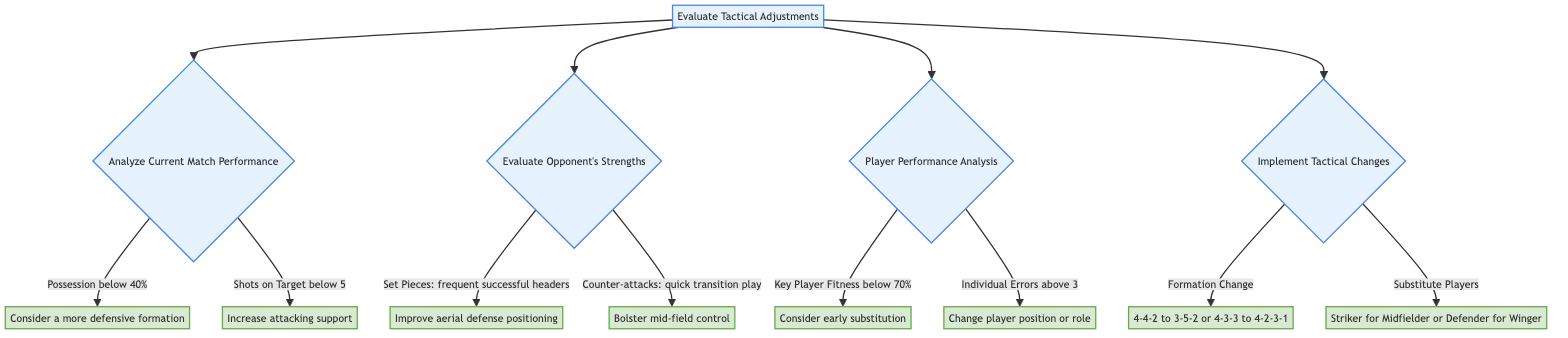What is the first node of the decision tree? The decision tree begins with the node titled "Evaluate Tactical Adjustments." This is the root node from which all subsequent decisions branch out.
Answer: Evaluate Tactical Adjustments How many main branches are there in this decision tree? The decision tree has four main branches stemming from the root node. Each branch represents a different aspect of tactical evaluation: current match performance, opponent's strengths, player performance, and implementing tactical changes.
Answer: 4 What action is suggested if possession is below 40%? The decision tree indicates that if possession is below 40%, the recommended action is to "Consider a more defensive formation." This suggests a tactical adjustment to improve ball control.
Answer: Consider a more defensive formation What should be done if individual errors are above 3? According to the diagram, if there are more than 3 individual errors, the recommended action is to "Change player position or role." This indicates a need to rectify performance issues.
Answer: Change player position or role What are the two options for a formation change? The decision tree provides two options for formation change: changing from "4-4-2 to 3-5-2" or from "4-3-3 to 4-2-3-1." Both options offer different tactical setups depending on match dynamics.
Answer: 4-4-2 to 3-5-2 or 4-3-3 to 4-2-3-1 What is the decision made when counter-attacks are frequent? If counter-attacks from the opponent involve quick transition play, the decision made is to "Bolster mid-field control." This aims to disrupt the opponent's attacking rhythm.
Answer: Bolster mid-field control What action should be taken if a key player's fitness is below 70%? The diagram advises that if a key player's fitness is below 70%, the action to be taken is to "Consider early substitution." This reflects a proactive approach to player management during a match.
Answer: Consider early substitution How are substitute players determined according to the decision tree? The decision on substitutes depends on identifying weak areas. The options presented are to substitute either a striker for a midfielder or a defender for a winger, based on the tactical evaluation.
Answer: Striker for Midfielder or Defender for Winger 